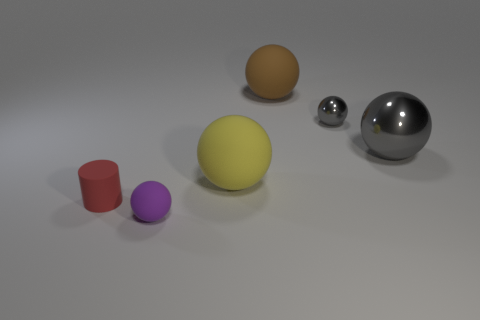Can you describe the shadows produced by the objects? The shadows produced by the objects are soft-edged and extend opposite to the direction of the light source. They vary in length and size corresponding to the size of each object and their position relative to the light, adding depth to the scene and enhancing the three-dimensional illusion. 